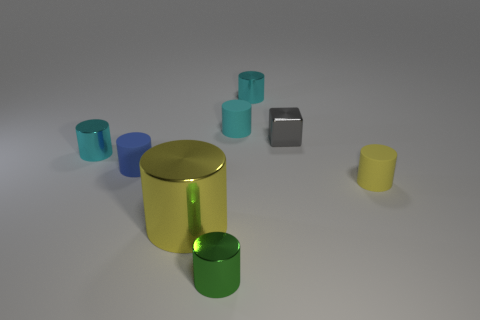Subtract all blue blocks. How many cyan cylinders are left? 3 Subtract all yellow cylinders. How many cylinders are left? 5 Subtract all tiny matte cylinders. How many cylinders are left? 4 Subtract all green cylinders. Subtract all brown spheres. How many cylinders are left? 6 Add 1 green objects. How many objects exist? 9 Subtract all blocks. How many objects are left? 7 Subtract all large blocks. Subtract all small yellow objects. How many objects are left? 7 Add 5 big yellow metal cylinders. How many big yellow metal cylinders are left? 6 Add 1 big yellow things. How many big yellow things exist? 2 Subtract 0 purple cubes. How many objects are left? 8 